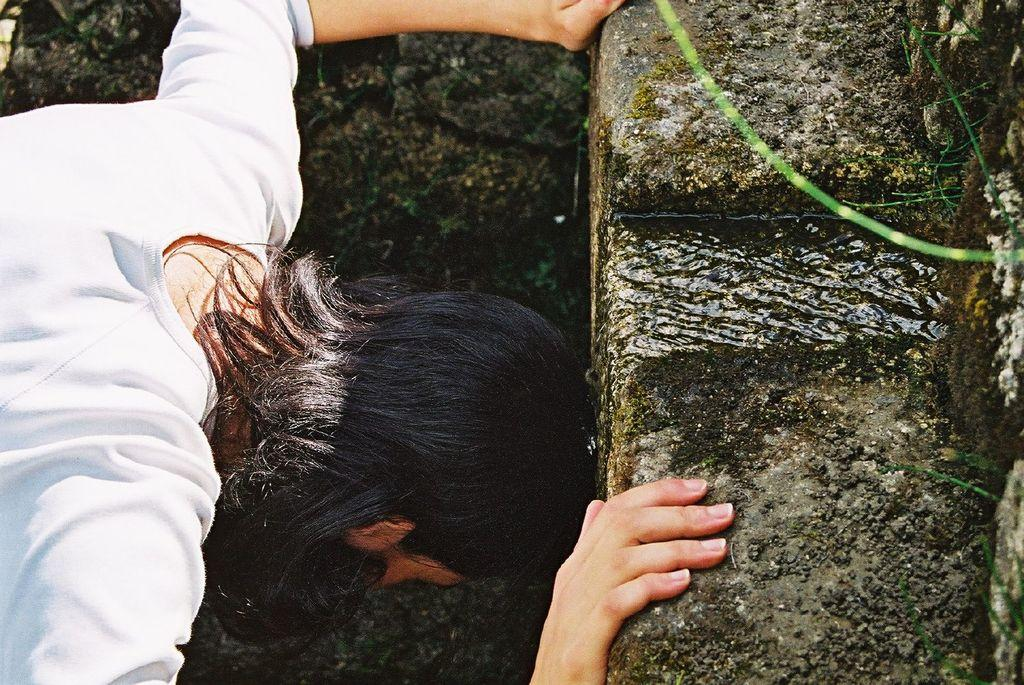What type of natural elements can be seen in the image? There are rocks and water visible in the image. Can you describe the person in the image? There is a person in the image, but no specific details about their appearance or actions are provided. What is located in the top right corner of the image? There are stems in the top right corner of the image. What type of reward is the person receiving for their expertise in the image? There is no indication in the image that the person is receiving a reward or that they possess any expertise. 